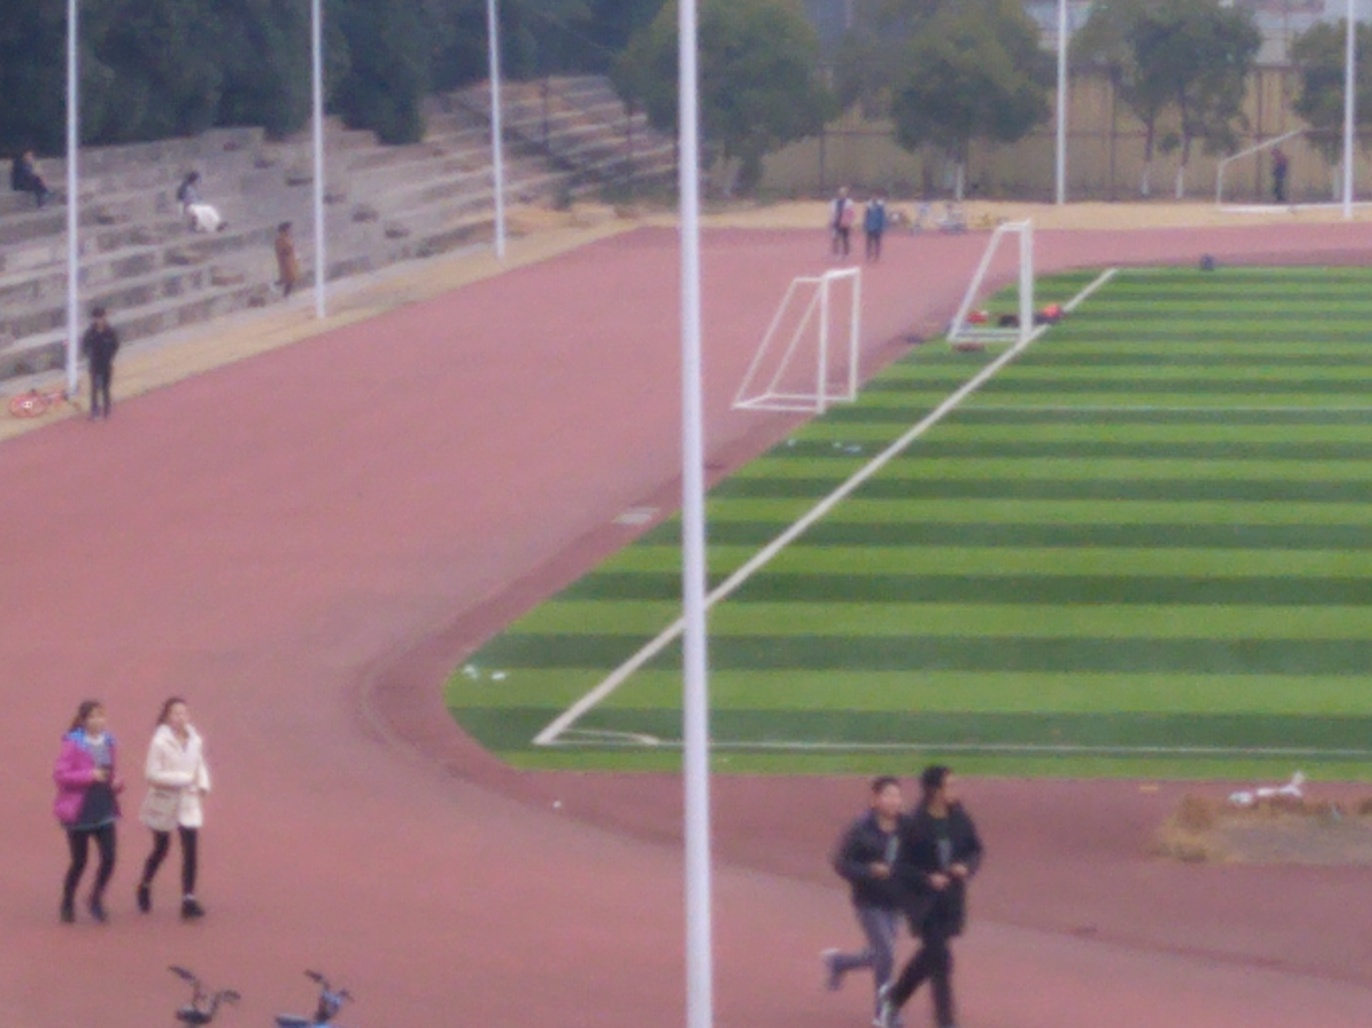Are there any people using the sports facility? Yes, there are several individuals present. Some appear to be walking along the track, and others are seated or standing in the areas adjacent to the sporting grounds, likely engaging in casual activities or watching. 